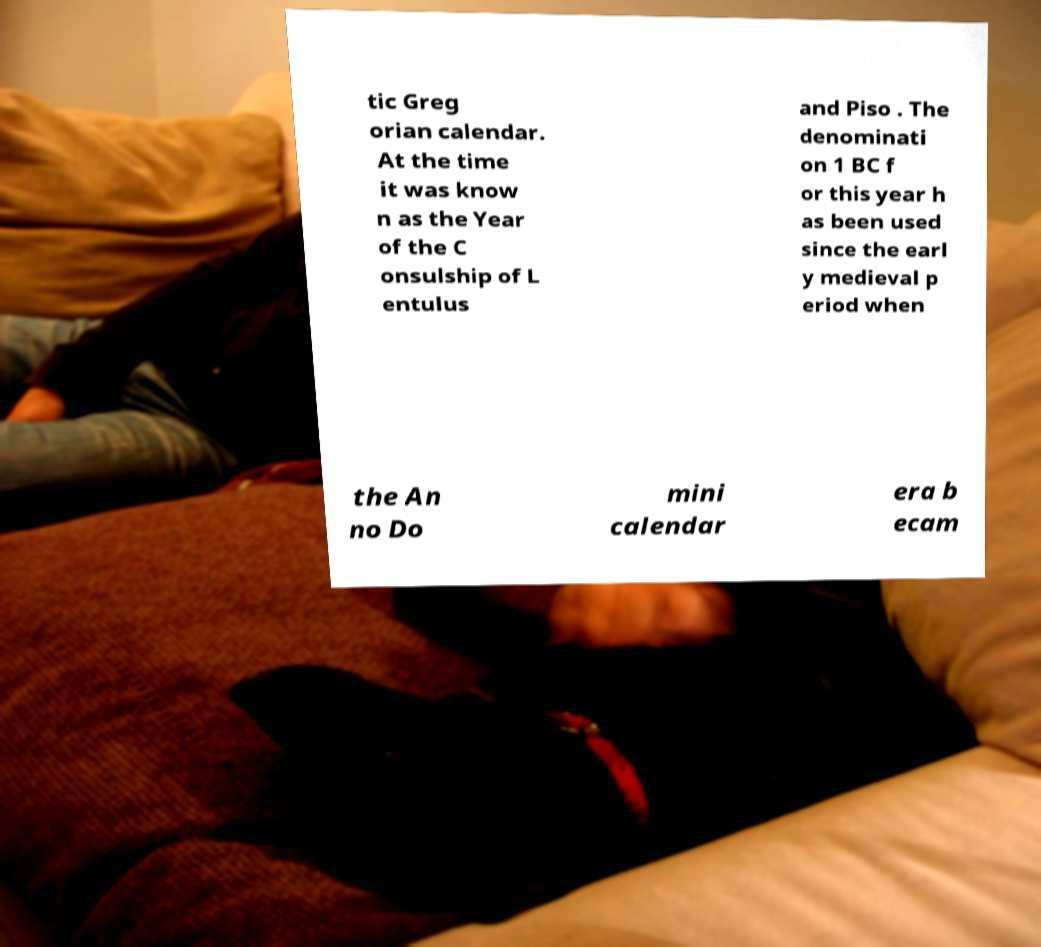Can you accurately transcribe the text from the provided image for me? tic Greg orian calendar. At the time it was know n as the Year of the C onsulship of L entulus and Piso . The denominati on 1 BC f or this year h as been used since the earl y medieval p eriod when the An no Do mini calendar era b ecam 